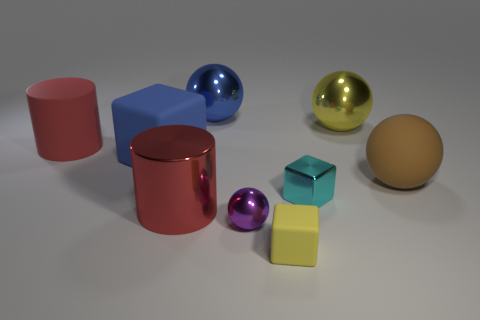Can you describe the lighting and shadows in the image? The lighting in the image appears to be coming from above, casting soft shadows on the ground to the right of the objects. This diffused illumination produces gentle shadows, lending the scene a calm and evenly lit atmosphere. 